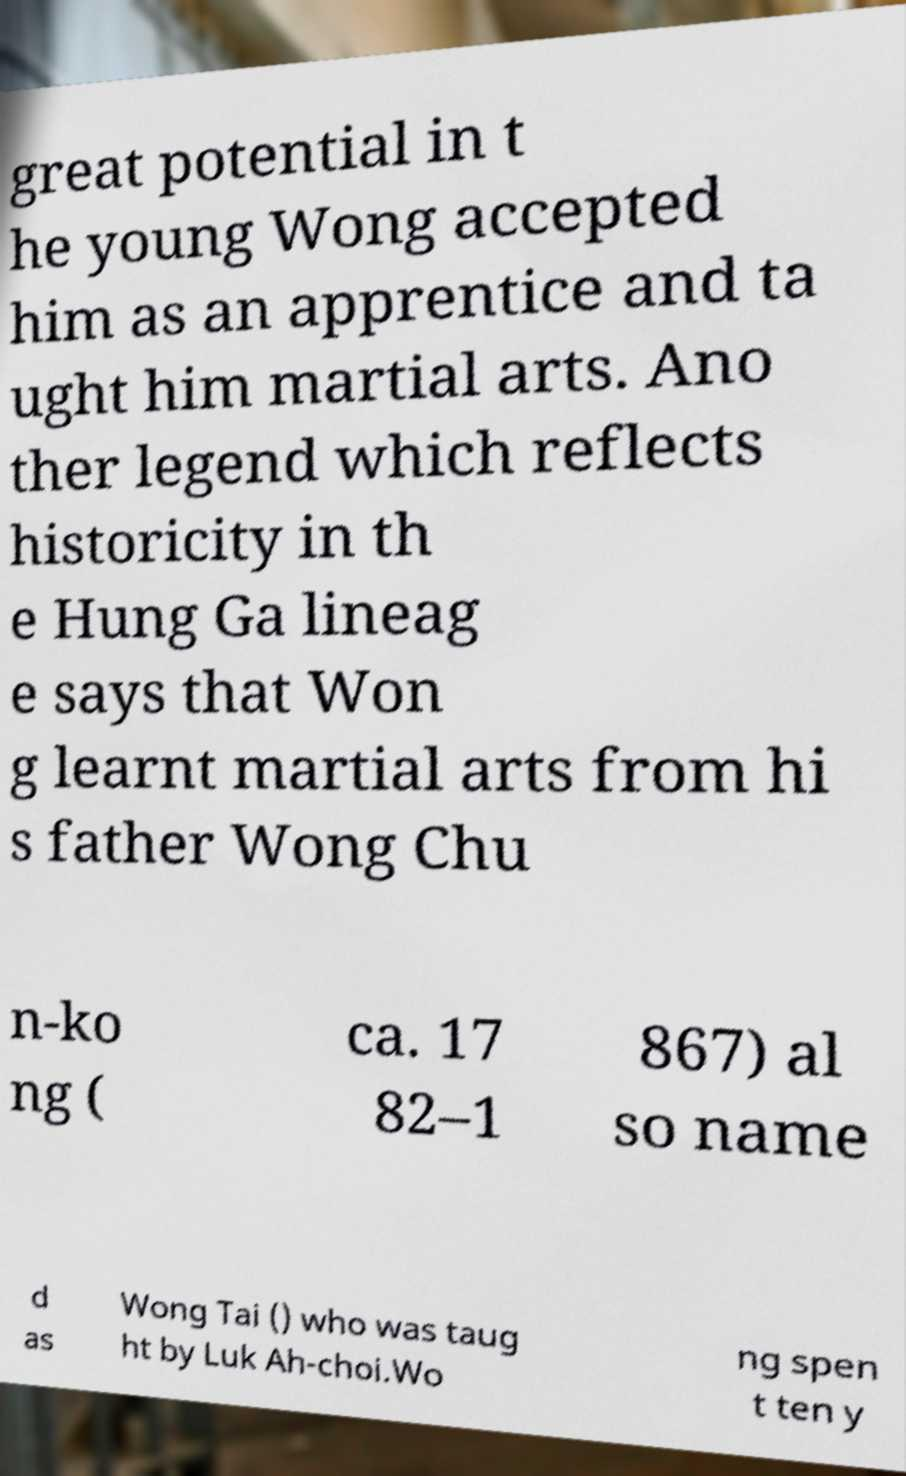Could you assist in decoding the text presented in this image and type it out clearly? great potential in t he young Wong accepted him as an apprentice and ta ught him martial arts. Ano ther legend which reflects historicity in th e Hung Ga lineag e says that Won g learnt martial arts from hi s father Wong Chu n-ko ng ( ca. 17 82–1 867) al so name d as Wong Tai () who was taug ht by Luk Ah-choi.Wo ng spen t ten y 